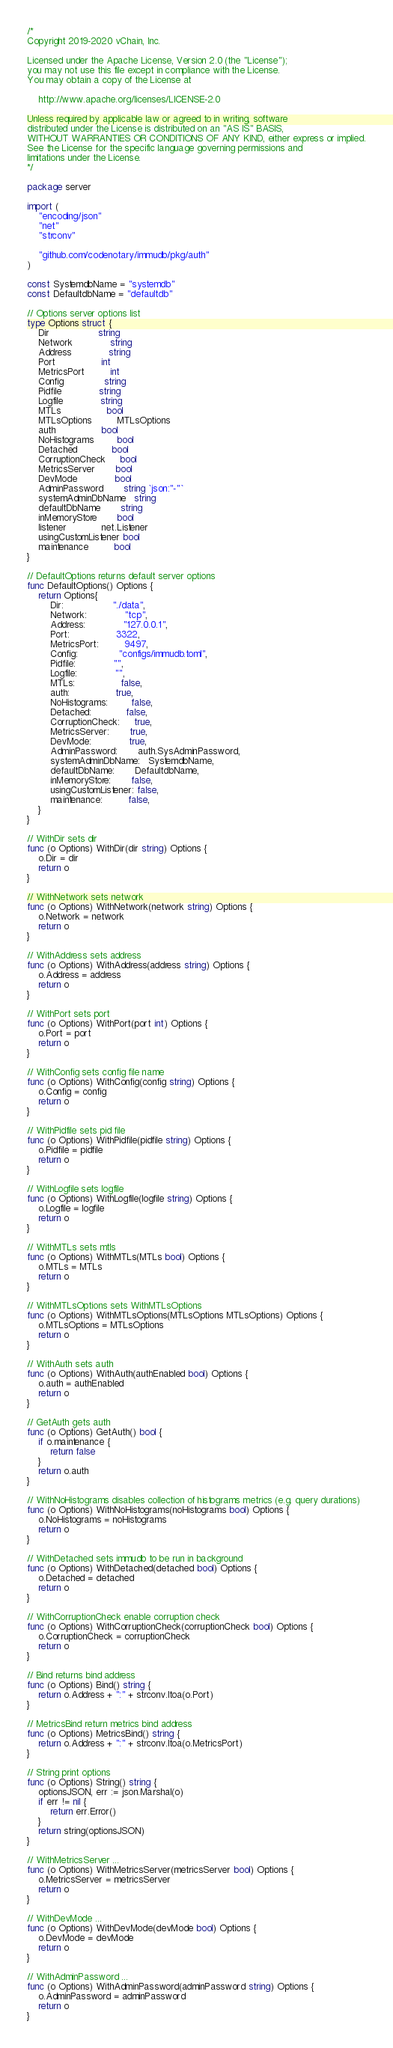<code> <loc_0><loc_0><loc_500><loc_500><_Go_>/*
Copyright 2019-2020 vChain, Inc.

Licensed under the Apache License, Version 2.0 (the "License");
you may not use this file except in compliance with the License.
You may obtain a copy of the License at

	http://www.apache.org/licenses/LICENSE-2.0

Unless required by applicable law or agreed to in writing, software
distributed under the License is distributed on an "AS IS" BASIS,
WITHOUT WARRANTIES OR CONDITIONS OF ANY KIND, either express or implied.
See the License for the specific language governing permissions and
limitations under the License.
*/

package server

import (
	"encoding/json"
	"net"
	"strconv"

	"github.com/codenotary/immudb/pkg/auth"
)

const SystemdbName = "systemdb"
const DefaultdbName = "defaultdb"

// Options server options list
type Options struct {
	Dir                 string
	Network             string
	Address             string
	Port                int
	MetricsPort         int
	Config              string
	Pidfile             string
	Logfile             string
	MTLs                bool
	MTLsOptions         MTLsOptions
	auth                bool
	NoHistograms        bool
	Detached            bool
	CorruptionCheck     bool
	MetricsServer       bool
	DevMode             bool
	AdminPassword       string `json:"-"`
	systemAdminDbName   string
	defaultDbName       string
	inMemoryStore       bool
	listener            net.Listener
	usingCustomListener bool
	maintenance         bool
}

// DefaultOptions returns default server options
func DefaultOptions() Options {
	return Options{
		Dir:                 "./data",
		Network:             "tcp",
		Address:             "127.0.0.1",
		Port:                3322,
		MetricsPort:         9497,
		Config:              "configs/immudb.toml",
		Pidfile:             "",
		Logfile:             "",
		MTLs:                false,
		auth:                true,
		NoHistograms:        false,
		Detached:            false,
		CorruptionCheck:     true,
		MetricsServer:       true,
		DevMode:             true,
		AdminPassword:       auth.SysAdminPassword,
		systemAdminDbName:   SystemdbName,
		defaultDbName:       DefaultdbName,
		inMemoryStore:       false,
		usingCustomListener: false,
		maintenance:         false,
	}
}

// WithDir sets dir
func (o Options) WithDir(dir string) Options {
	o.Dir = dir
	return o
}

// WithNetwork sets network
func (o Options) WithNetwork(network string) Options {
	o.Network = network
	return o
}

// WithAddress sets address
func (o Options) WithAddress(address string) Options {
	o.Address = address
	return o
}

// WithPort sets port
func (o Options) WithPort(port int) Options {
	o.Port = port
	return o
}

// WithConfig sets config file name
func (o Options) WithConfig(config string) Options {
	o.Config = config
	return o
}

// WithPidfile sets pid file
func (o Options) WithPidfile(pidfile string) Options {
	o.Pidfile = pidfile
	return o
}

// WithLogfile sets logfile
func (o Options) WithLogfile(logfile string) Options {
	o.Logfile = logfile
	return o
}

// WithMTLs sets mtls
func (o Options) WithMTLs(MTLs bool) Options {
	o.MTLs = MTLs
	return o
}

// WithMTLsOptions sets WithMTLsOptions
func (o Options) WithMTLsOptions(MTLsOptions MTLsOptions) Options {
	o.MTLsOptions = MTLsOptions
	return o
}

// WithAuth sets auth
func (o Options) WithAuth(authEnabled bool) Options {
	o.auth = authEnabled
	return o
}

// GetAuth gets auth
func (o Options) GetAuth() bool {
	if o.maintenance {
		return false
	}
	return o.auth
}

// WithNoHistograms disables collection of histograms metrics (e.g. query durations)
func (o Options) WithNoHistograms(noHistograms bool) Options {
	o.NoHistograms = noHistograms
	return o
}

// WithDetached sets immudb to be run in background
func (o Options) WithDetached(detached bool) Options {
	o.Detached = detached
	return o
}

// WithCorruptionCheck enable corruption check
func (o Options) WithCorruptionCheck(corruptionCheck bool) Options {
	o.CorruptionCheck = corruptionCheck
	return o
}

// Bind returns bind address
func (o Options) Bind() string {
	return o.Address + ":" + strconv.Itoa(o.Port)
}

// MetricsBind return metrics bind address
func (o Options) MetricsBind() string {
	return o.Address + ":" + strconv.Itoa(o.MetricsPort)
}

// String print options
func (o Options) String() string {
	optionsJSON, err := json.Marshal(o)
	if err != nil {
		return err.Error()
	}
	return string(optionsJSON)
}

// WithMetricsServer ...
func (o Options) WithMetricsServer(metricsServer bool) Options {
	o.MetricsServer = metricsServer
	return o
}

// WithDevMode ...
func (o Options) WithDevMode(devMode bool) Options {
	o.DevMode = devMode
	return o
}

// WithAdminPassword ...
func (o Options) WithAdminPassword(adminPassword string) Options {
	o.AdminPassword = adminPassword
	return o
}
</code> 